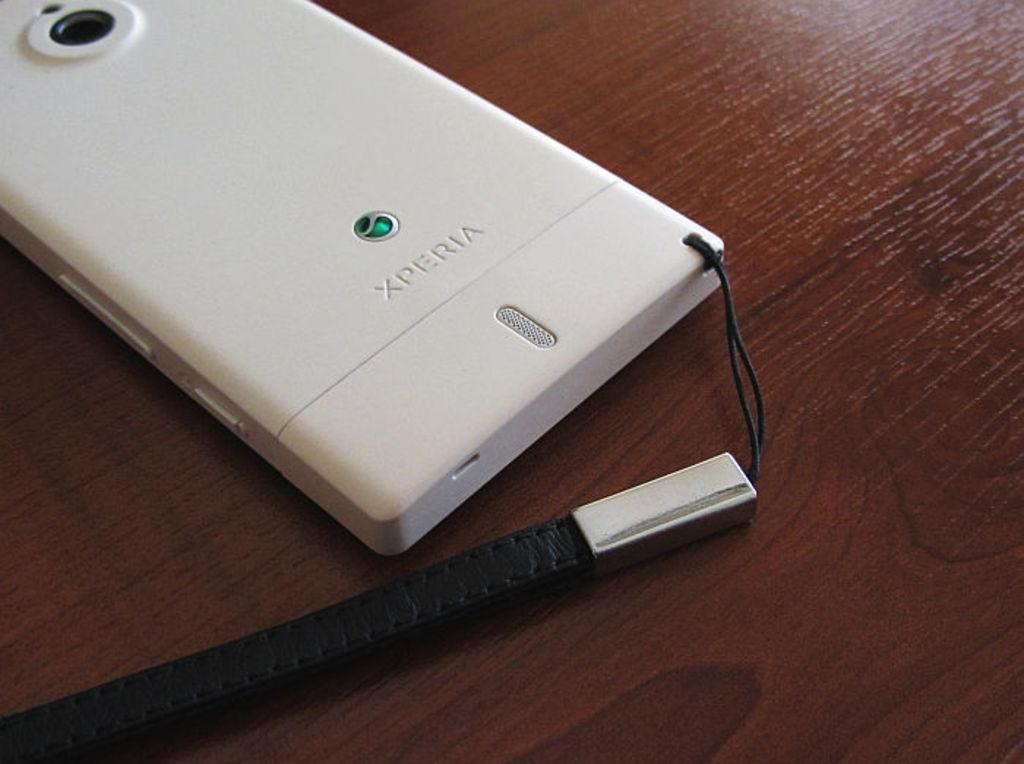Provide a one-sentence caption for the provided image. The back of a white phone shows that it is from Xperia. 